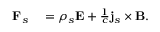Convert formula to latex. <formula><loc_0><loc_0><loc_500><loc_500>\begin{array} { r l } { F _ { s } } & = \rho _ { s } E + \frac { 1 } { c } j _ { s } \times B . } \end{array}</formula> 